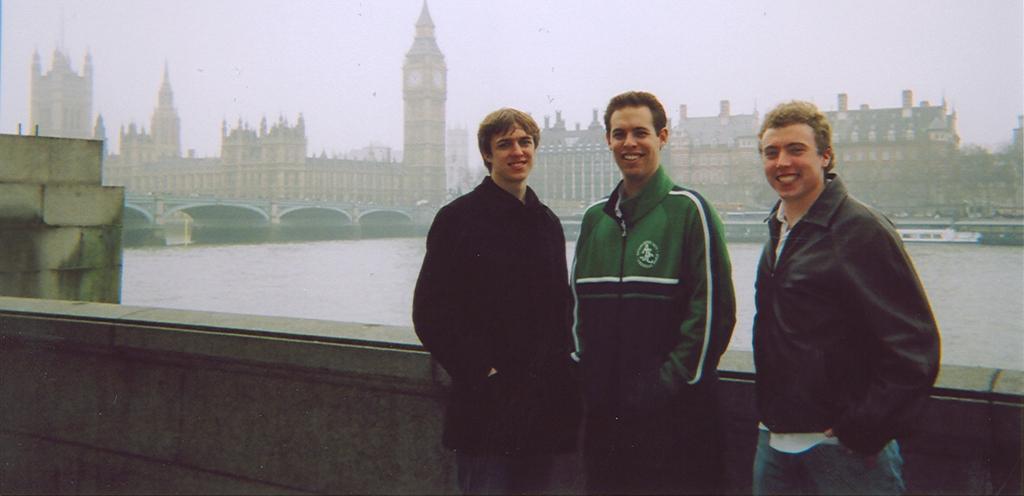Describe this image in one or two sentences. In the center of the image there are three persons standing. In the background of the image there are buildings,bridge and water. 